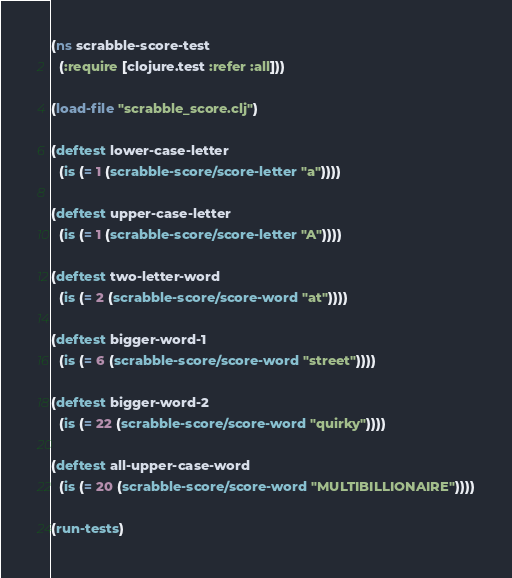Convert code to text. <code><loc_0><loc_0><loc_500><loc_500><_Clojure_>(ns scrabble-score-test
  (:require [clojure.test :refer :all]))

(load-file "scrabble_score.clj")

(deftest lower-case-letter
  (is (= 1 (scrabble-score/score-letter "a"))))

(deftest upper-case-letter
  (is (= 1 (scrabble-score/score-letter "A"))))

(deftest two-letter-word
  (is (= 2 (scrabble-score/score-word "at"))))

(deftest bigger-word-1
  (is (= 6 (scrabble-score/score-word "street"))))

(deftest bigger-word-2
  (is (= 22 (scrabble-score/score-word "quirky"))))

(deftest all-upper-case-word
  (is (= 20 (scrabble-score/score-word "MULTIBILLIONAIRE"))))

(run-tests)
</code> 